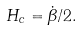Convert formula to latex. <formula><loc_0><loc_0><loc_500><loc_500>H _ { c } = \dot { \beta } / 2 .</formula> 